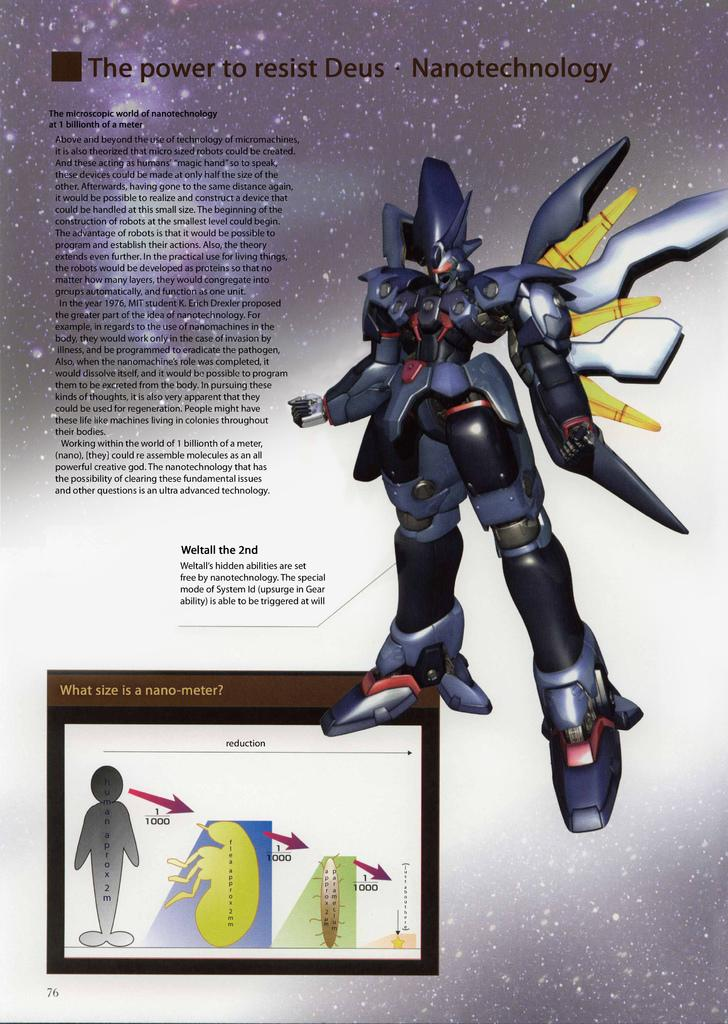<image>
Create a compact narrative representing the image presented. An article about resisting Deus and Nanotechnology along with a illustration of what is through to be Deus. 